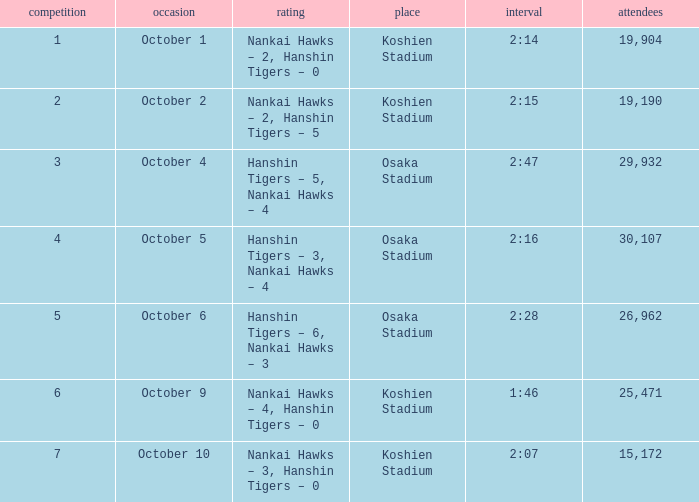Which Score has a Time of 2:28? Hanshin Tigers – 6, Nankai Hawks – 3. Would you be able to parse every entry in this table? {'header': ['competition', 'occasion', 'rating', 'place', 'interval', 'attendees'], 'rows': [['1', 'October 1', 'Nankai Hawks – 2, Hanshin Tigers – 0', 'Koshien Stadium', '2:14', '19,904'], ['2', 'October 2', 'Nankai Hawks – 2, Hanshin Tigers – 5', 'Koshien Stadium', '2:15', '19,190'], ['3', 'October 4', 'Hanshin Tigers – 5, Nankai Hawks – 4', 'Osaka Stadium', '2:47', '29,932'], ['4', 'October 5', 'Hanshin Tigers – 3, Nankai Hawks – 4', 'Osaka Stadium', '2:16', '30,107'], ['5', 'October 6', 'Hanshin Tigers – 6, Nankai Hawks – 3', 'Osaka Stadium', '2:28', '26,962'], ['6', 'October 9', 'Nankai Hawks – 4, Hanshin Tigers – 0', 'Koshien Stadium', '1:46', '25,471'], ['7', 'October 10', 'Nankai Hawks – 3, Hanshin Tigers – 0', 'Koshien Stadium', '2:07', '15,172']]} 